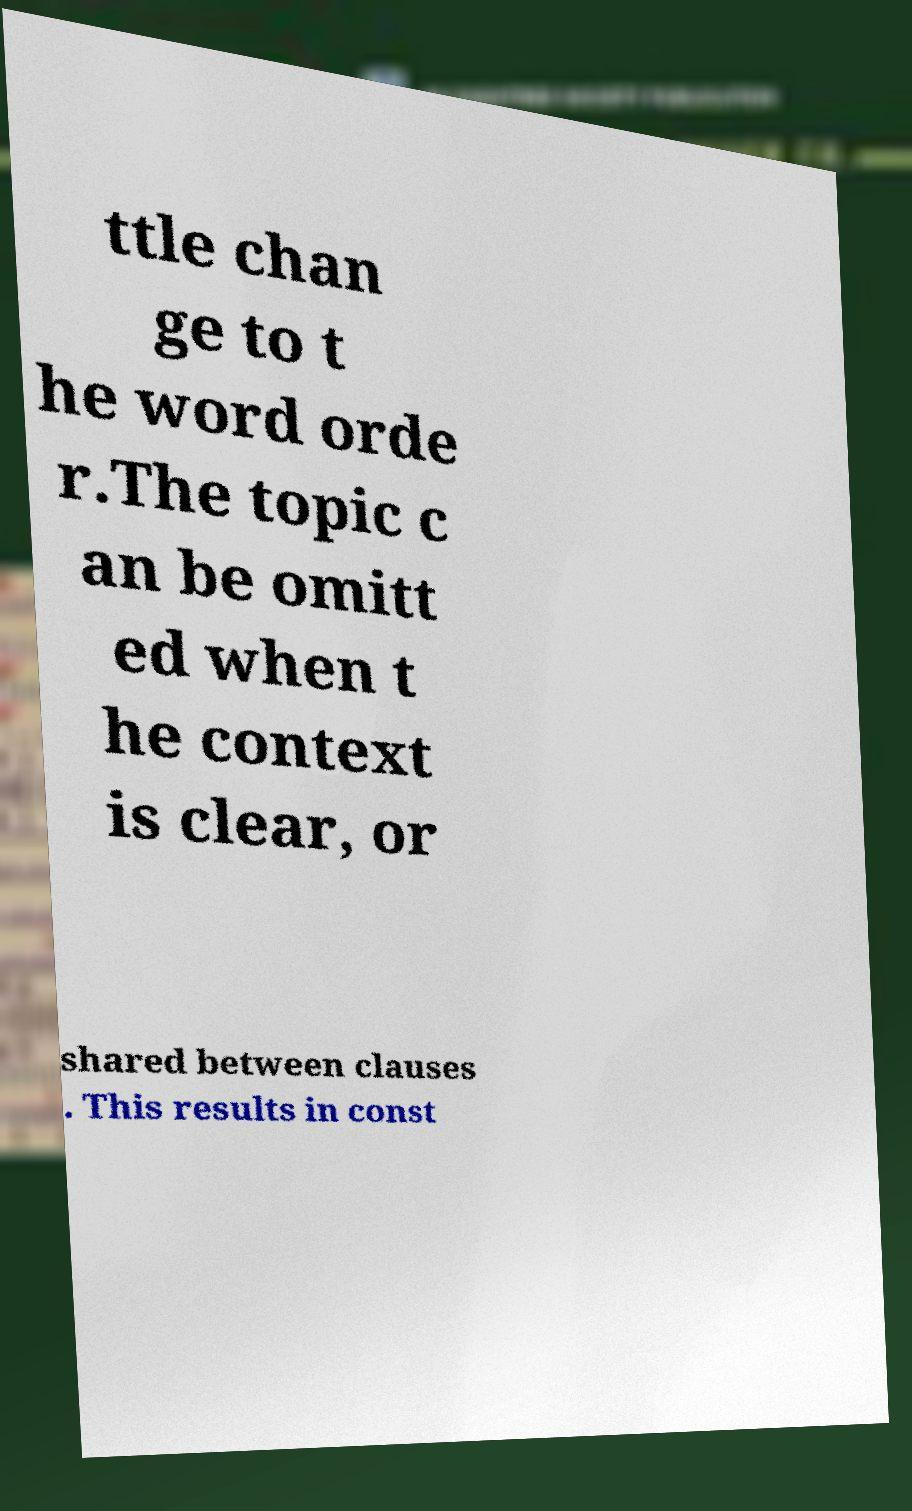Please identify and transcribe the text found in this image. ttle chan ge to t he word orde r.The topic c an be omitt ed when t he context is clear, or shared between clauses . This results in const 